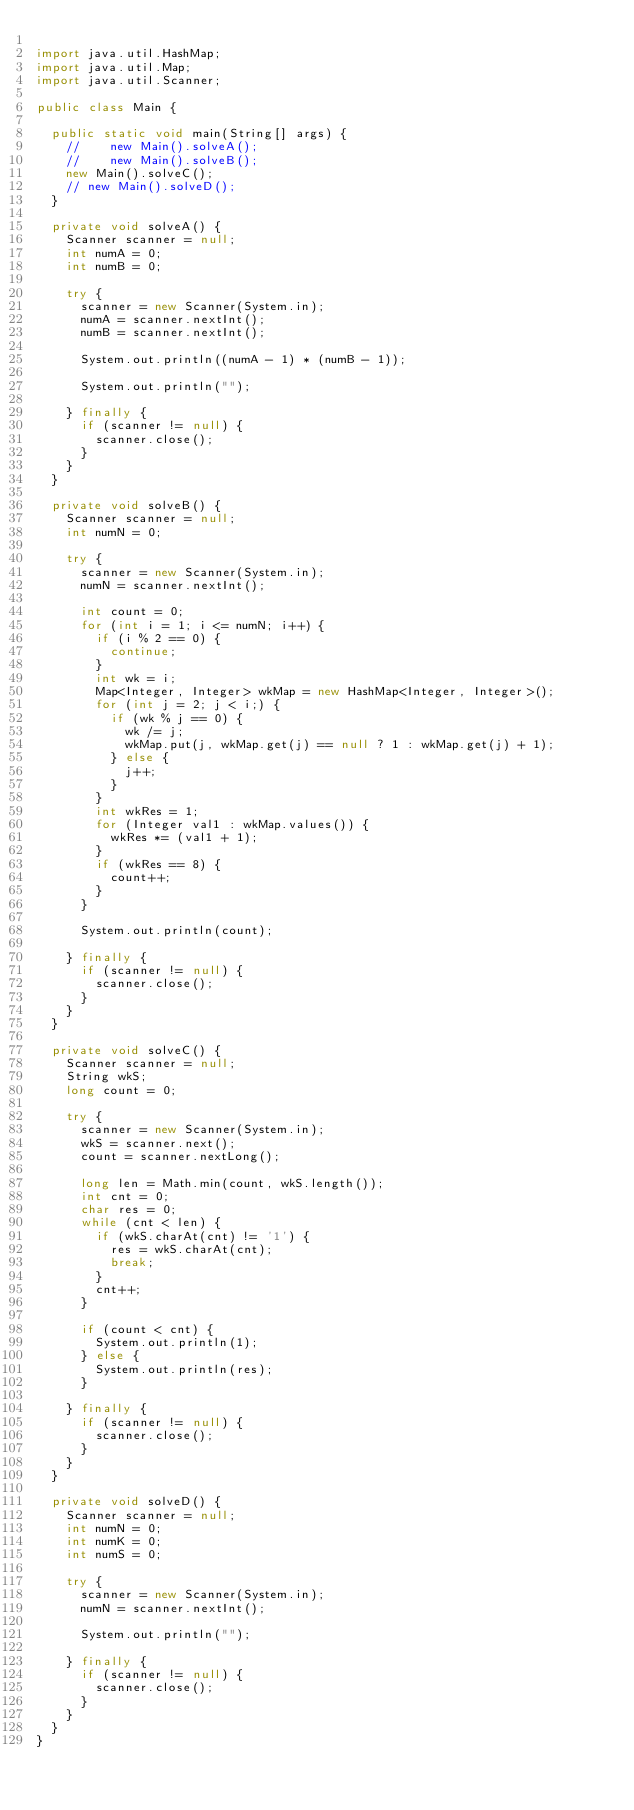<code> <loc_0><loc_0><loc_500><loc_500><_Java_>
import java.util.HashMap;
import java.util.Map;
import java.util.Scanner;

public class Main {

	public static void main(String[] args) {
		//		new Main().solveA();
		//		new Main().solveB();
		new Main().solveC();
		// new Main().solveD();
	}

	private void solveA() {
		Scanner scanner = null;
		int numA = 0;
		int numB = 0;

		try {
			scanner = new Scanner(System.in);
			numA = scanner.nextInt();
			numB = scanner.nextInt();

			System.out.println((numA - 1) * (numB - 1));

			System.out.println("");

		} finally {
			if (scanner != null) {
				scanner.close();
			}
		}
	}

	private void solveB() {
		Scanner scanner = null;
		int numN = 0;

		try {
			scanner = new Scanner(System.in);
			numN = scanner.nextInt();

			int count = 0;
			for (int i = 1; i <= numN; i++) {
				if (i % 2 == 0) {
					continue;
				}
				int wk = i;
				Map<Integer, Integer> wkMap = new HashMap<Integer, Integer>();
				for (int j = 2; j < i;) {
					if (wk % j == 0) {
						wk /= j;
						wkMap.put(j, wkMap.get(j) == null ? 1 : wkMap.get(j) + 1);
					} else {
						j++;
					}
				}
				int wkRes = 1;
				for (Integer val1 : wkMap.values()) {
					wkRes *= (val1 + 1);
				}
				if (wkRes == 8) {
					count++;
				}
			}

			System.out.println(count);

		} finally {
			if (scanner != null) {
				scanner.close();
			}
		}
	}

	private void solveC() {
		Scanner scanner = null;
		String wkS;
		long count = 0;

		try {
			scanner = new Scanner(System.in);
			wkS = scanner.next();
			count = scanner.nextLong();

			long len = Math.min(count, wkS.length());
			int cnt = 0;
			char res = 0;
			while (cnt < len) {
				if (wkS.charAt(cnt) != '1') {
					res = wkS.charAt(cnt);
					break;
				}
				cnt++;
			}

			if (count < cnt) {
				System.out.println(1);
			} else {
				System.out.println(res);
			}

		} finally {
			if (scanner != null) {
				scanner.close();
			}
		}
	}

	private void solveD() {
		Scanner scanner = null;
		int numN = 0;
		int numK = 0;
		int numS = 0;

		try {
			scanner = new Scanner(System.in);
			numN = scanner.nextInt();

			System.out.println("");

		} finally {
			if (scanner != null) {
				scanner.close();
			}
		}
	}
}</code> 